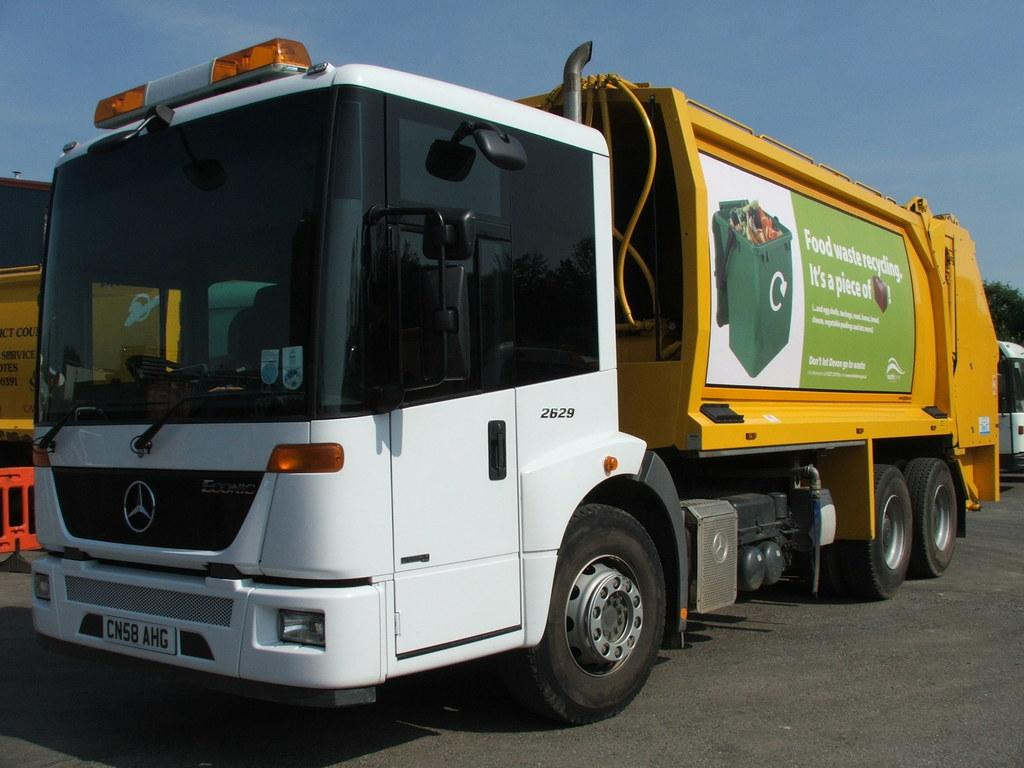<image>
Create a compact narrative representing the image presented. the words food waste that is on a truck 